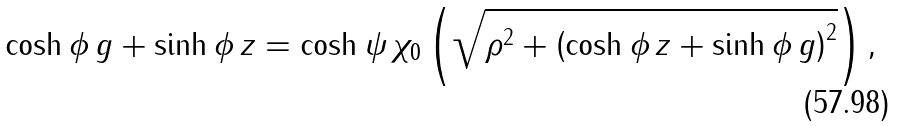Convert formula to latex. <formula><loc_0><loc_0><loc_500><loc_500>\cosh \phi \, g + \sinh \phi \, z = \cosh \psi \, \chi _ { 0 } \left ( \sqrt { \rho ^ { 2 } + \left ( \cosh \phi \, z + \sinh \phi \, g \right ) ^ { 2 } } \right ) ,</formula> 